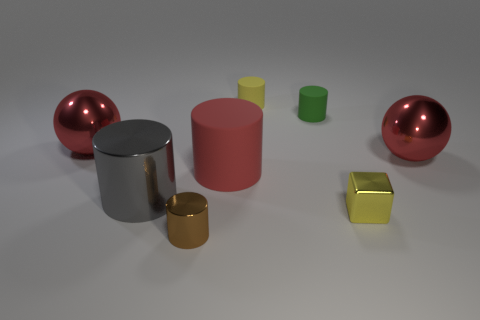Subtract all metallic cylinders. How many cylinders are left? 3 Add 2 tiny red spheres. How many objects exist? 10 Subtract all yellow cylinders. How many cylinders are left? 4 Subtract 2 cylinders. How many cylinders are left? 3 Subtract all big rubber cubes. Subtract all yellow cylinders. How many objects are left? 7 Add 2 gray metallic cylinders. How many gray metallic cylinders are left? 3 Add 5 gray metal things. How many gray metal things exist? 6 Subtract 1 gray cylinders. How many objects are left? 7 Subtract all blocks. How many objects are left? 7 Subtract all cyan cubes. Subtract all red cylinders. How many cubes are left? 1 